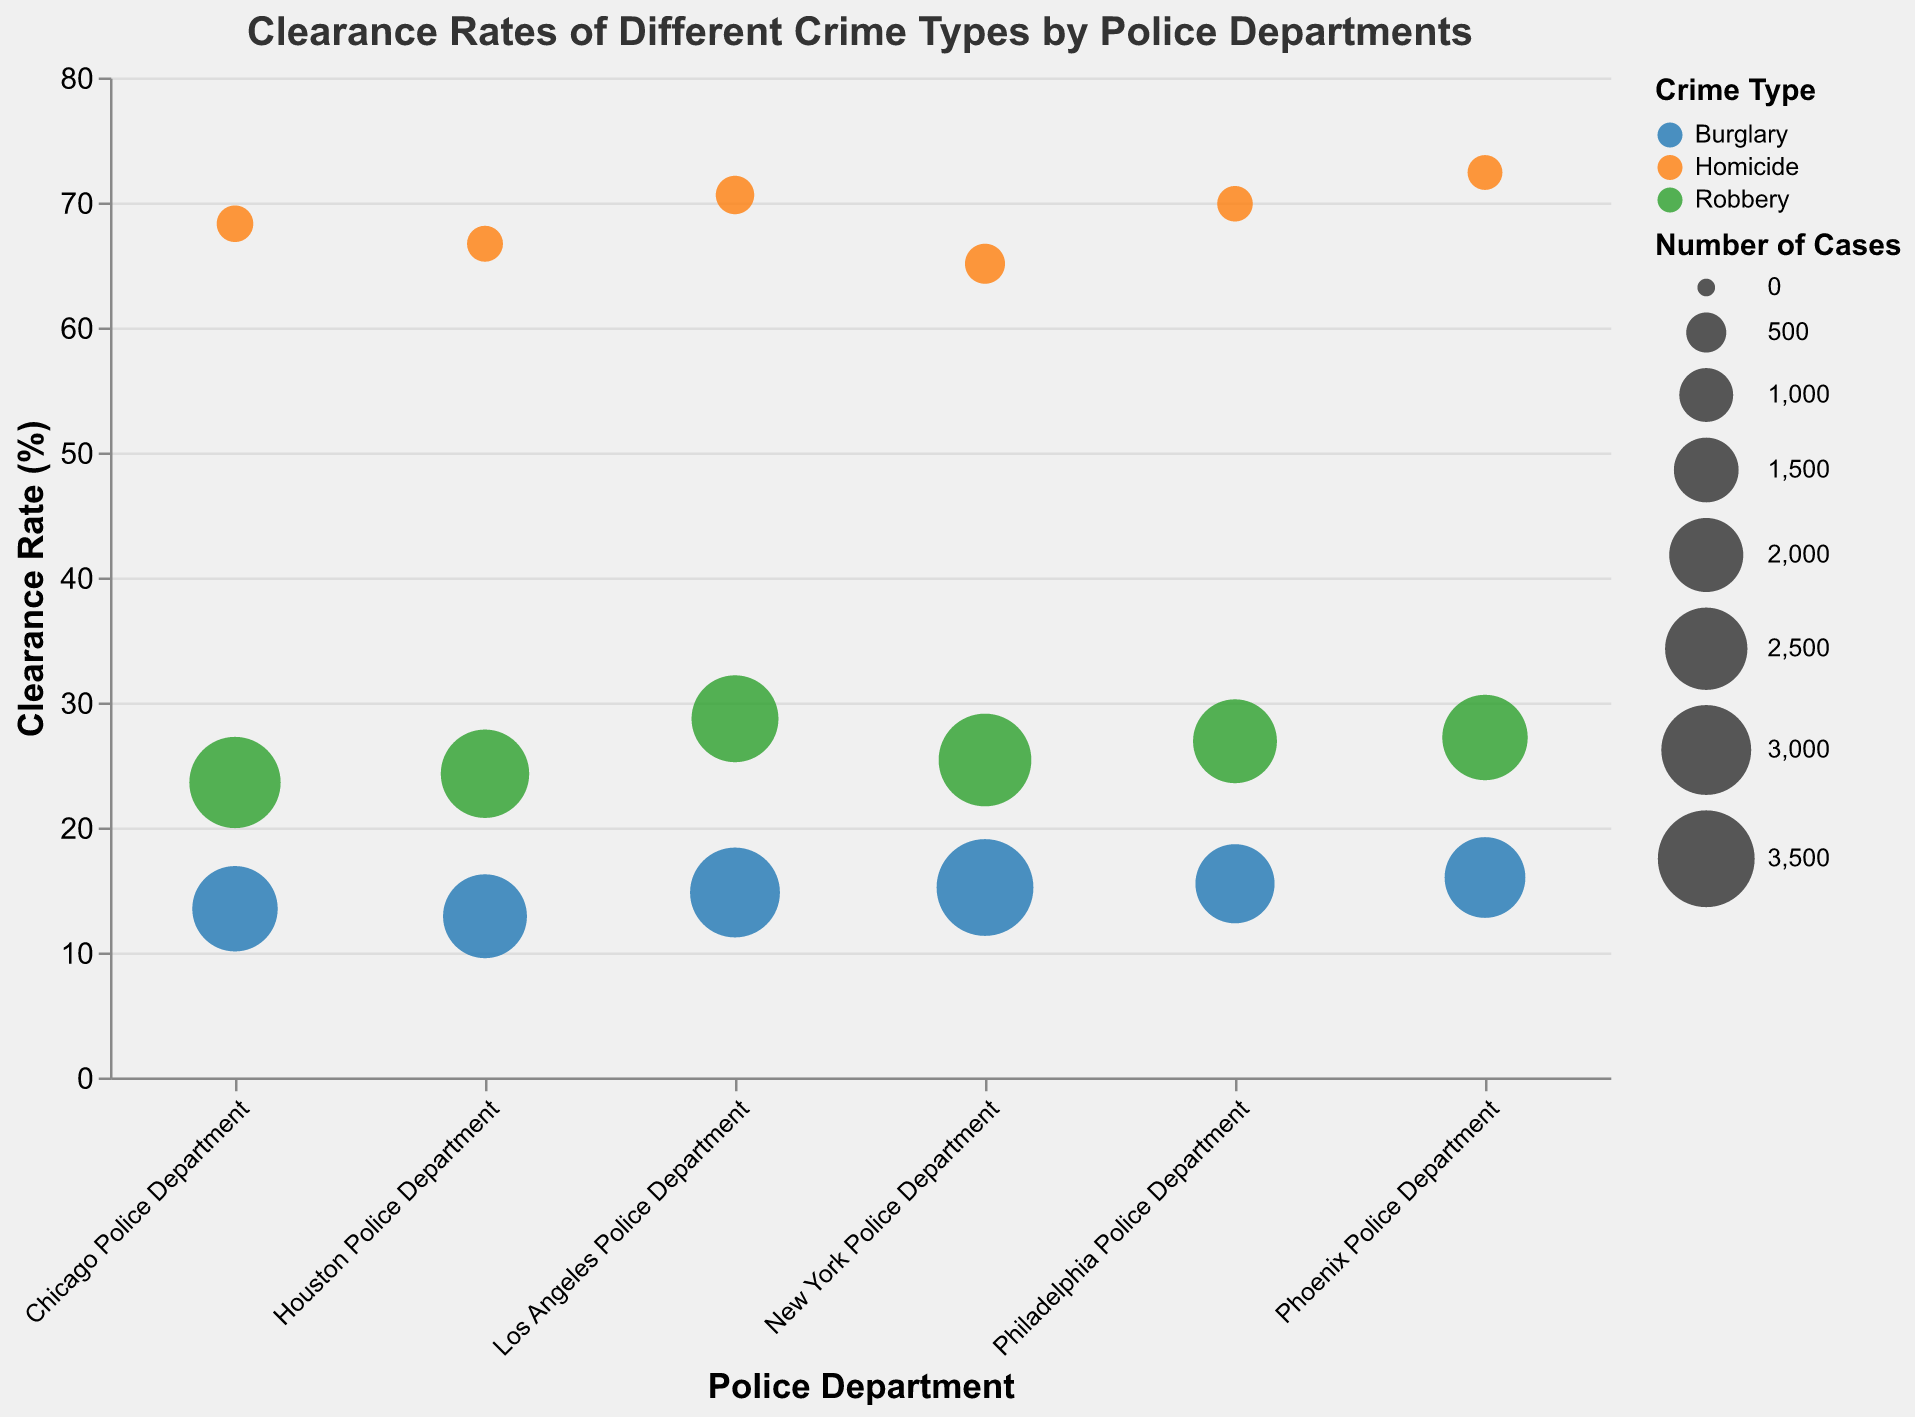How many crime types are displayed for the New York Police Department? To count the number of distinct crime types for the New York Police Department, look at the different colored circles under "New York Police Department" on the x-axis. These represent the different crime types.
Answer: 3 Which police department has the highest clearance rate for Homicide? Check which data point under each police department category on the x-axis has the highest y-value (clearance rate) for the crime type "Homicide" which is color-coded.
Answer: Phoenix Police Department What is the clearance rate of Robbery for Los Angeles Police Department? Find the data point under the Los Angeles Police Department that corresponds to the crime type "Robbery". Look at the y-axis value for this point to find the clearance rate.
Answer: 28.7% Which crime type generally has the lowest clearance rates across all police departments? Compare the clearance rates (y-axis values) for Burglary, Homicide, and Robbery across all police departments. The crime type with generally the lowest clearance rates can be identified.
Answer: Burglary How many police departments have a clearance rate above 70% for Homicide? Identify which data points associated with the crime type "Homicide" (specific color) have y-values above 70%, then count the number of corresponding police departments.
Answer: 2 For which crime type does Chicago Police Department have the smallest number of cases? Compare the sizes of the bubbles corresponding to the Chicago Police Department. The smallest bubble indicates the crime type with the fewest cases.
Answer: Homicide Which police department handles the largest number of burglary cases and what is this number? Look for the largest bubble under the crime type "Burglary" on the x-axis. The size of the bubble represents the number of cases.
Answer: New York Police Department, 3500 What is the correlation between the number of cases and the clearance rate for Robbery across all departments? Analyze the size and position (y-value) of the bubbles for the crime type "Robbery" across different police departments to determine if larger bubbles tend to have higher or lower clearance rates.
Answer: No clear correlation Are clearance rates more consistent across departments for Homicide or Robbery? Compare the variance in y-values (clearance rates) for the data points associated with Homicide and Robbery across all departments. Less variance implies more consistency.
Answer: Homicide 